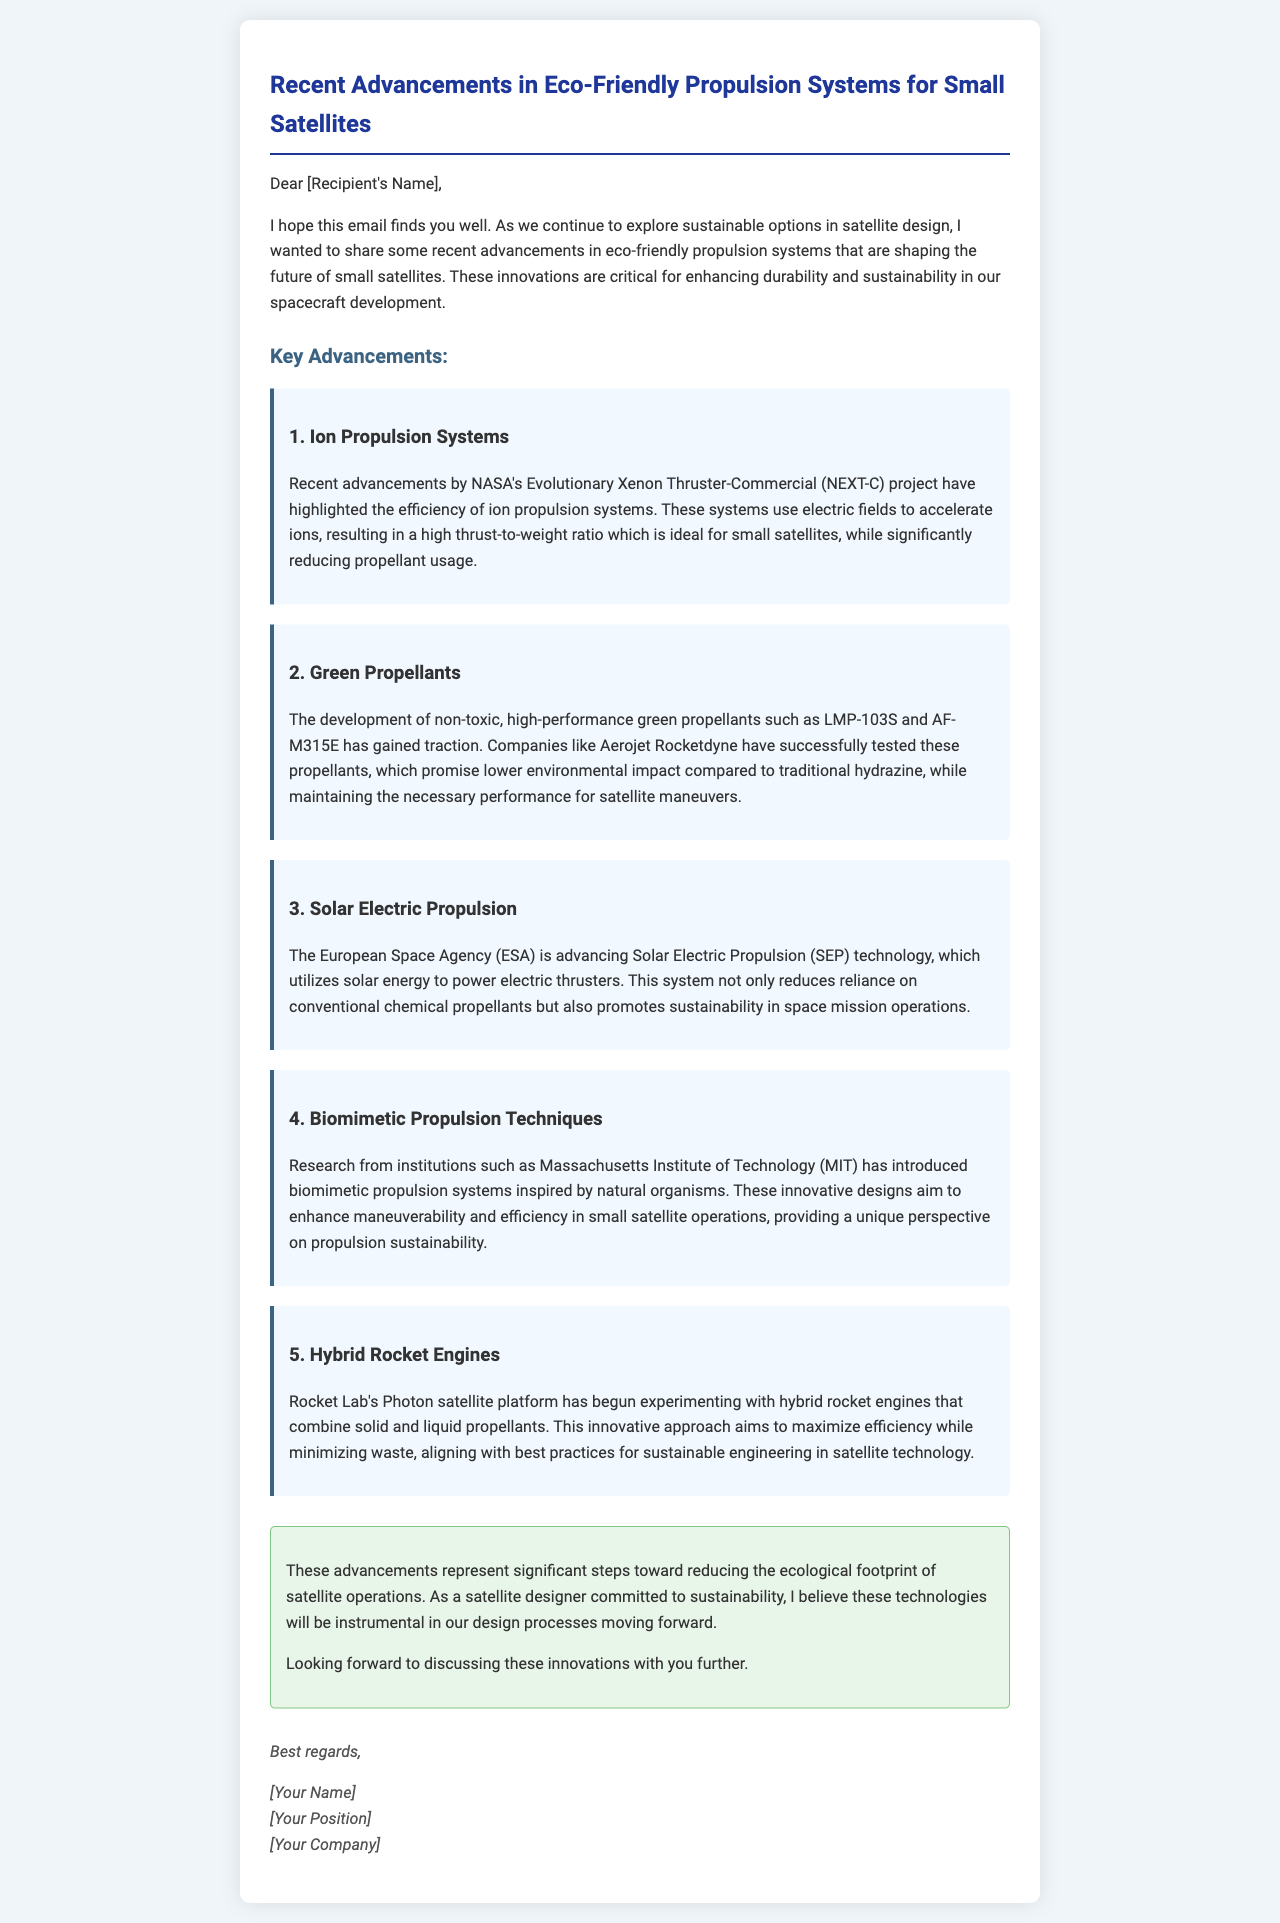what is the title of the email? The title of the email is stated prominently at the top of the document.
Answer: Recent Advancements in Eco-Friendly Propulsion Systems for Small Satellites who is conducting research on Biomimetic Propulsion Techniques? The email mentions a specific institution that is involved in this research.
Answer: Massachusetts Institute of Technology (MIT) what type of propulsion system uses electric fields? The email describes a specific technology that employs electric fields for propulsion.
Answer: Ion Propulsion Systems which green propellant was tested by Aerojet Rocketdyne? The email lists a specific green propellant related to the testing conducted by this company.
Answer: LMP-103S what is a key benefit of Solar Electric Propulsion? The email highlights a major advantage provided by the Solar Electric Propulsion technology.
Answer: Reduces reliance on conventional chemical propellants how do hybrid rocket engines aim to achieve sustainability? The email explains the method through which hybrid rocket engines contribute to sustainable engineering.
Answer: Maximize efficiency while minimizing waste what does the conclusion suggest about the significance of these advancements? The conclusion emphasizes the importance of the discussed technologies in satellite design.
Answer: Significant steps toward reducing the ecological footprint what is the main purpose of the email? The overall intent of the email is made clear in the opening paragraph.
Answer: Share recent advancements in eco-friendly propulsion systems 